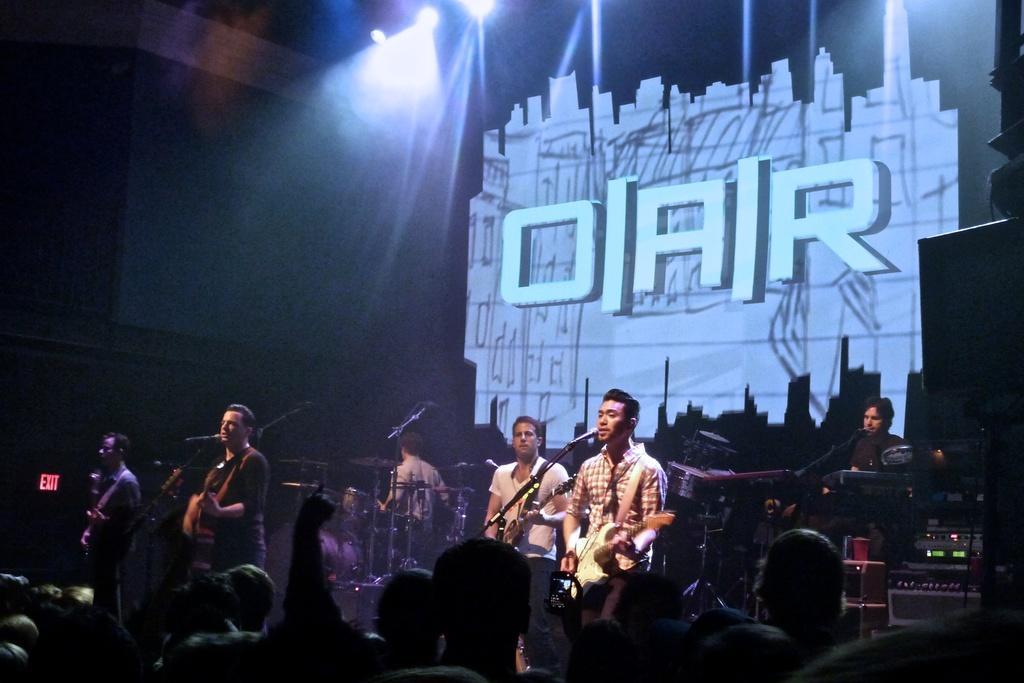How would you summarize this image in a sentence or two? In this picture we can see some people on stage playing musical instruments such as guitar, drums and singing on mics and in front of them crowd of people looking at them and in background we can see light, banner. 